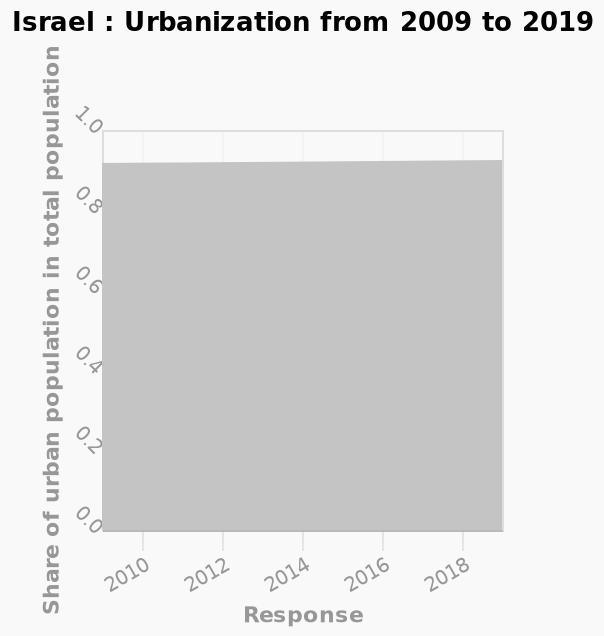<image>
What does the y-axis measure in the area graph? The y-axis measures the share of urban population in the total population. 